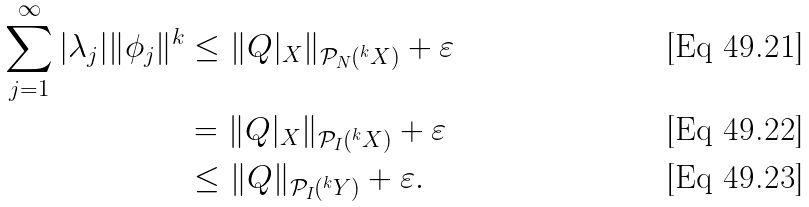Convert formula to latex. <formula><loc_0><loc_0><loc_500><loc_500>\sum _ { j = 1 } ^ { \infty } | \lambda _ { j } | \| \phi _ { j } \| ^ { k } & \leq \| Q | _ { X } \| _ { \mathcal { P } _ { N } ( ^ { k } X ) } + \varepsilon \\ & = \| Q | _ { X } \| _ { \mathcal { P } _ { I } ( ^ { k } X ) } + \varepsilon \\ & \leq \| Q \| _ { \mathcal { P } _ { I } ( ^ { k } Y ) } + \varepsilon .</formula> 